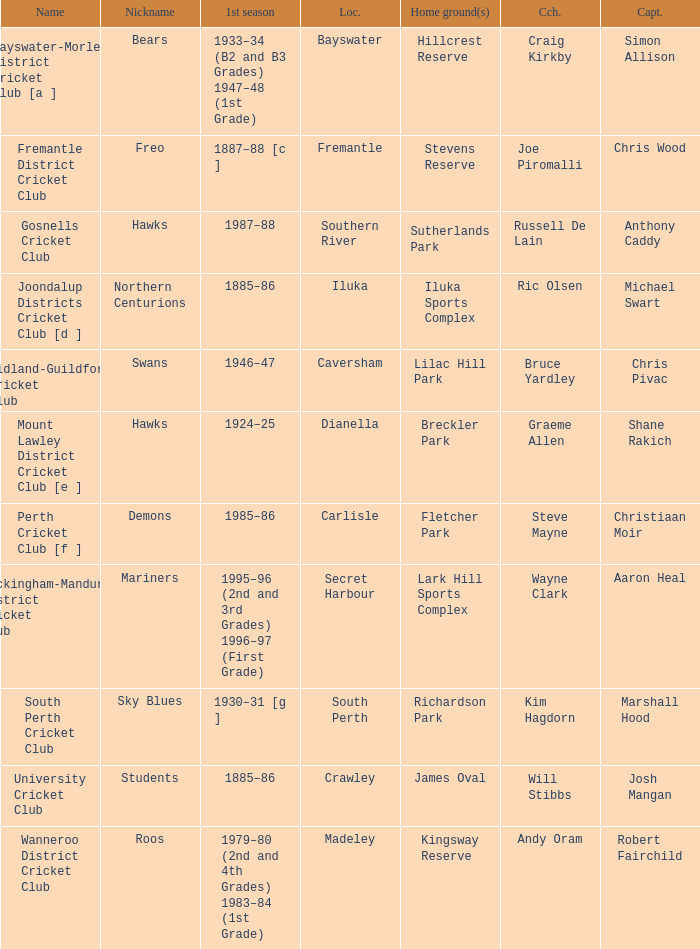With the nickname the swans, what is the home ground? Lilac Hill Park. 